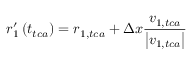Convert formula to latex. <formula><loc_0><loc_0><loc_500><loc_500>r _ { 1 } ^ { \prime } \left ( t _ { t c a } \right ) = r _ { 1 , t c a } + \Delta x \frac { \ v { v } _ { 1 , t c a } } { \left | \ v { v } _ { 1 , t c a } \right | }</formula> 